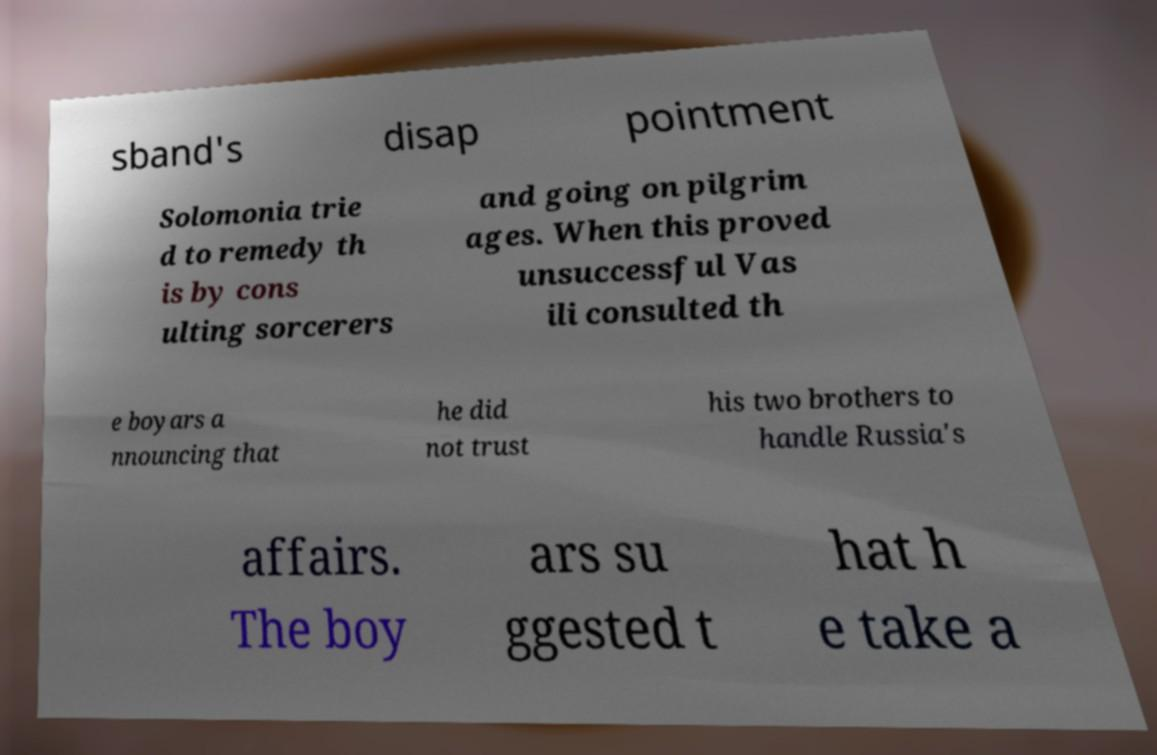Please read and relay the text visible in this image. What does it say? sband's disap pointment Solomonia trie d to remedy th is by cons ulting sorcerers and going on pilgrim ages. When this proved unsuccessful Vas ili consulted th e boyars a nnouncing that he did not trust his two brothers to handle Russia's affairs. The boy ars su ggested t hat h e take a 